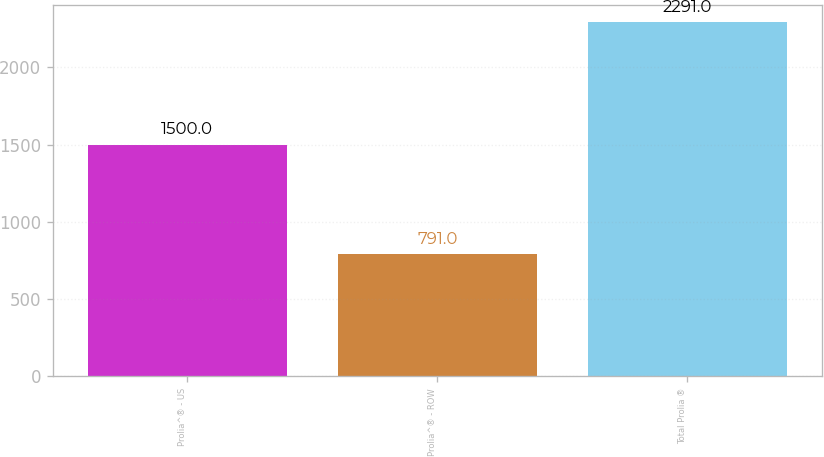Convert chart. <chart><loc_0><loc_0><loc_500><loc_500><bar_chart><fcel>Prolia^® - US<fcel>Prolia^® - ROW<fcel>Total Prolia ®<nl><fcel>1500<fcel>791<fcel>2291<nl></chart> 